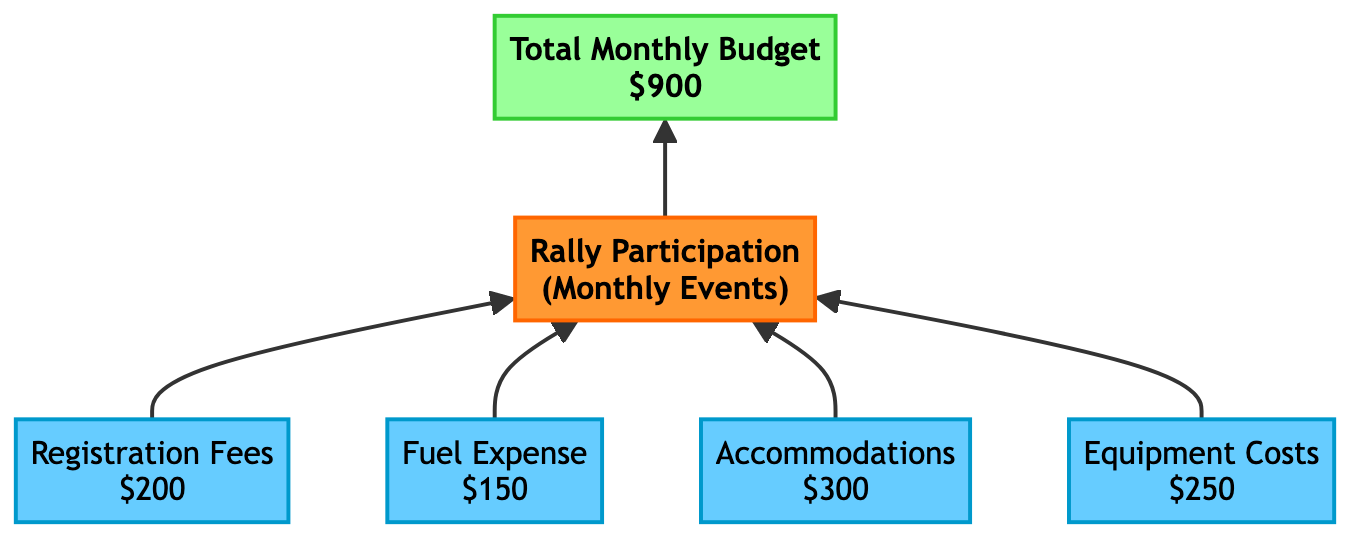What is the total monthly budget for rally participation? The diagram clearly states the "Total Monthly Budget" node, which summarizes all expenses incurred for rally participation. The value given is "$900".
Answer: $900 What are the expenses associated with registration fees? The node for "Registration Fees" in the diagram shows the cost associated with signing up for rally events. The specific expense listed is "$200".
Answer: $200 How many expenses are there for rally participation? Counting the nodes for expense types in the diagram, we find four: "Registration Fees", "Fuel Expense", "Accommodations", and "Equipment Costs". Therefore, there are four expenses listed.
Answer: 4 What is the expense for accommodations? The "Accommodations" node specifies the cost of lodging during rally events, which is shown as "$300".
Answer: $300 Which expense has the highest cost? By comparing the values of all expenses listed in the diagram ("Registration Fees" - $200, "Fuel Expense" - $150, "Accommodations" - $300, and "Equipment Costs" - $250), it is found that "Accommodations" has the highest cost at "$300".
Answer: Accommodations What is the relationship between "Fuel Expense" and "Rally Participation"? The diagram shows that "Fuel Expense" leads directly to the "Rally Participation" event, indicating that it is a contributing factor to the overall participation expenses.
Answer: Contributing factor How many types of nodes are present in the diagram? The diagram consists of three types of nodes: "Event", "Expense", and "Summary". By examining the classifications, we affirm that there are three distinct node types depicted.
Answer: 3 What is the total of registration fees and fuel expenses? By adding the values of the "Registration Fees" ($200) and "Fuel Expense" ($150) nodes, we calculate $200 + $150 = $350 for the combined total.
Answer: $350 What color represents expense nodes in the diagram? The diagram indicates that expense nodes are filled with the color "#66CCFF" and have the stroke color "#0099CC", denoting them as expense-related items clearly.
Answer: #66CCFF 